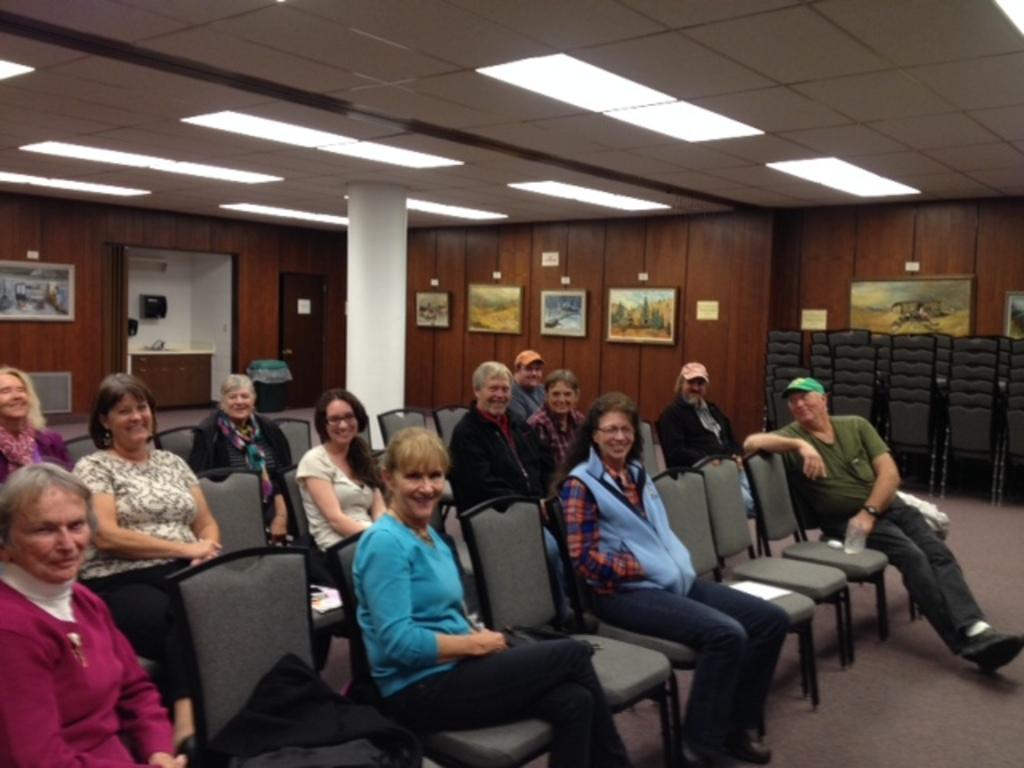How many people are in the image? There is a group of people in the image. What are the people doing in the image? The people are seated on chairs. What expressions do the people have in the image? The people have smiles on their faces. What can be seen on the wall in the image? There are photo frames on the wall. What is on the roof in the image? There are lights on the roof. What type of brush can be seen in the hands of one of the people in the image? There is no brush visible in the hands of any person in the image. 